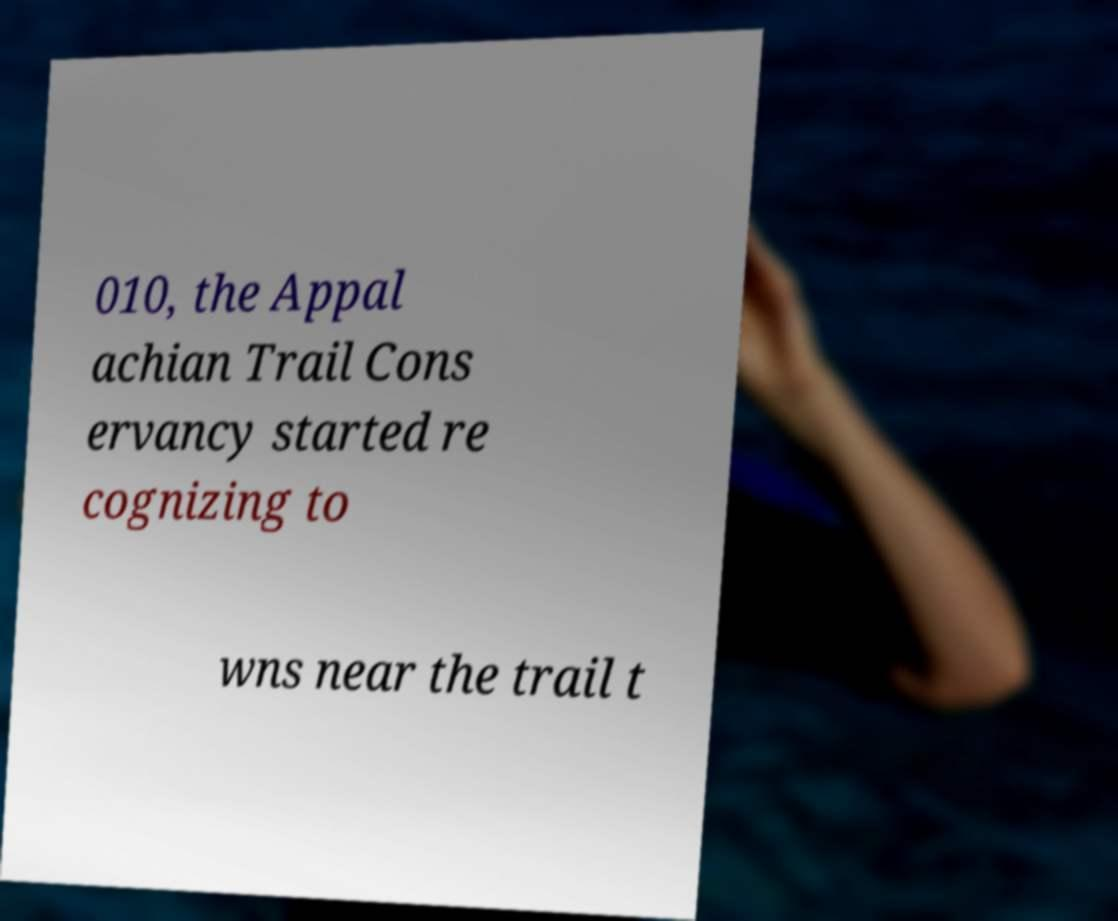For documentation purposes, I need the text within this image transcribed. Could you provide that? 010, the Appal achian Trail Cons ervancy started re cognizing to wns near the trail t 